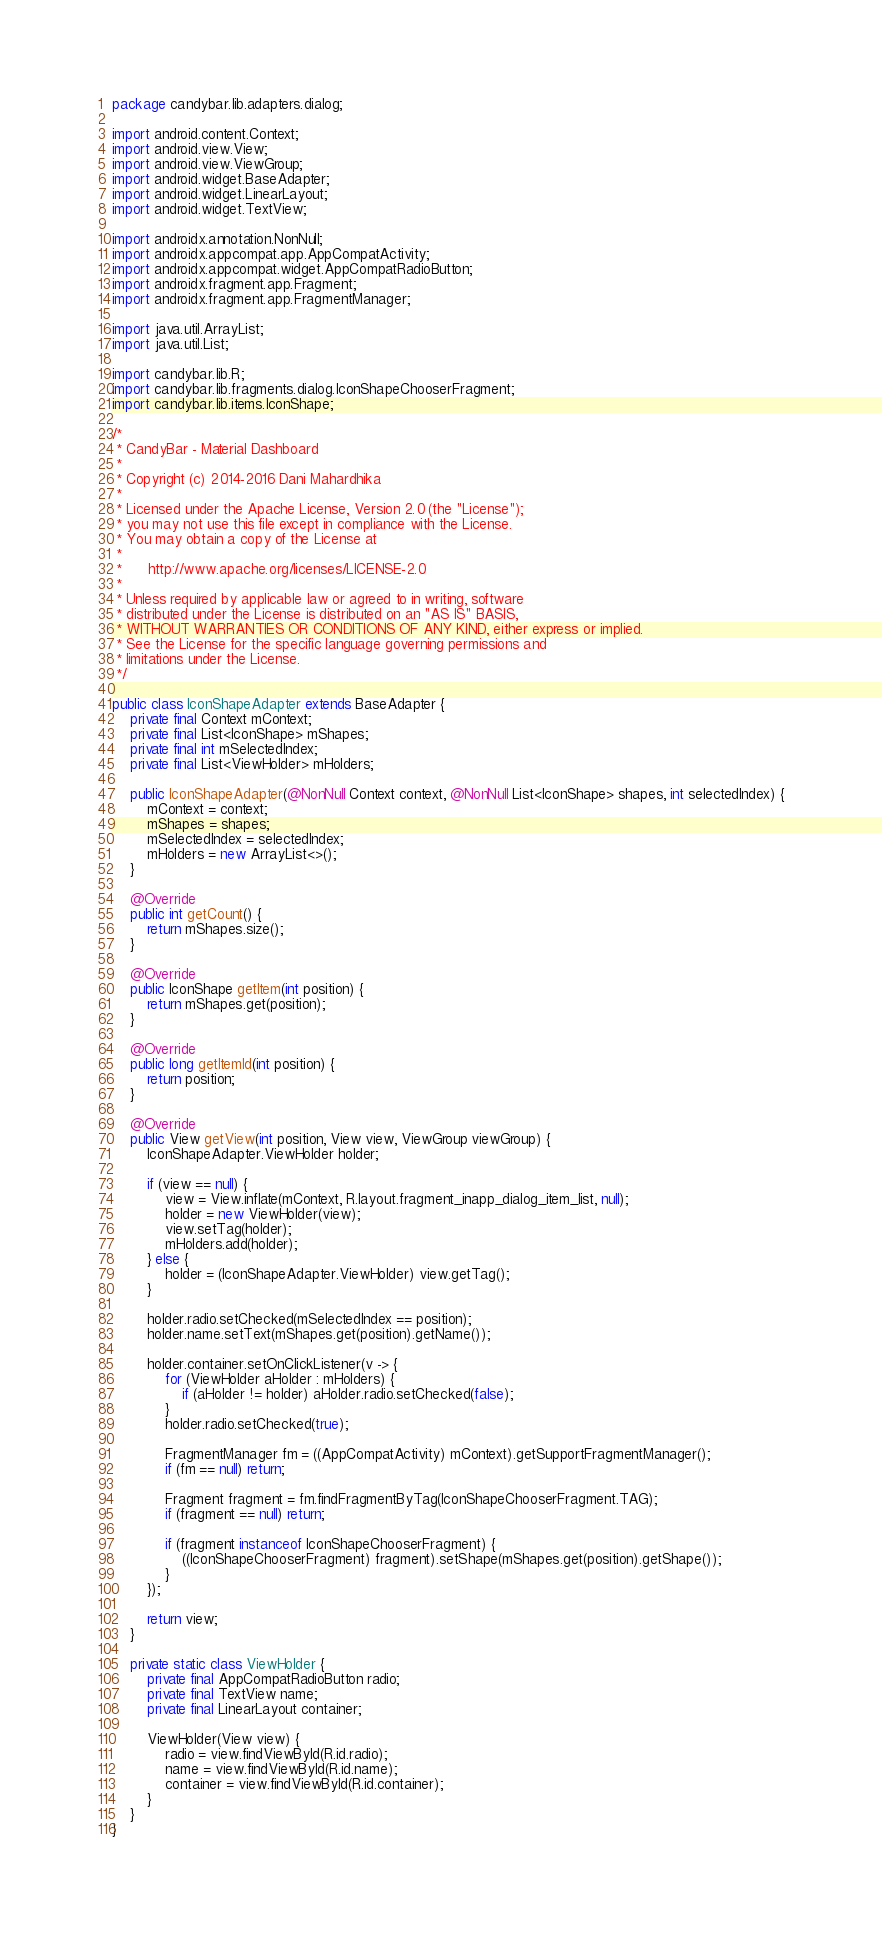<code> <loc_0><loc_0><loc_500><loc_500><_Java_>package candybar.lib.adapters.dialog;

import android.content.Context;
import android.view.View;
import android.view.ViewGroup;
import android.widget.BaseAdapter;
import android.widget.LinearLayout;
import android.widget.TextView;

import androidx.annotation.NonNull;
import androidx.appcompat.app.AppCompatActivity;
import androidx.appcompat.widget.AppCompatRadioButton;
import androidx.fragment.app.Fragment;
import androidx.fragment.app.FragmentManager;

import java.util.ArrayList;
import java.util.List;

import candybar.lib.R;
import candybar.lib.fragments.dialog.IconShapeChooserFragment;
import candybar.lib.items.IconShape;

/*
 * CandyBar - Material Dashboard
 *
 * Copyright (c) 2014-2016 Dani Mahardhika
 *
 * Licensed under the Apache License, Version 2.0 (the "License");
 * you may not use this file except in compliance with the License.
 * You may obtain a copy of the License at
 *
 *      http://www.apache.org/licenses/LICENSE-2.0
 *
 * Unless required by applicable law or agreed to in writing, software
 * distributed under the License is distributed on an "AS IS" BASIS,
 * WITHOUT WARRANTIES OR CONDITIONS OF ANY KIND, either express or implied.
 * See the License for the specific language governing permissions and
 * limitations under the License.
 */

public class IconShapeAdapter extends BaseAdapter {
    private final Context mContext;
    private final List<IconShape> mShapes;
    private final int mSelectedIndex;
    private final List<ViewHolder> mHolders;

    public IconShapeAdapter(@NonNull Context context, @NonNull List<IconShape> shapes, int selectedIndex) {
        mContext = context;
        mShapes = shapes;
        mSelectedIndex = selectedIndex;
        mHolders = new ArrayList<>();
    }

    @Override
    public int getCount() {
        return mShapes.size();
    }

    @Override
    public IconShape getItem(int position) {
        return mShapes.get(position);
    }

    @Override
    public long getItemId(int position) {
        return position;
    }

    @Override
    public View getView(int position, View view, ViewGroup viewGroup) {
        IconShapeAdapter.ViewHolder holder;

        if (view == null) {
            view = View.inflate(mContext, R.layout.fragment_inapp_dialog_item_list, null);
            holder = new ViewHolder(view);
            view.setTag(holder);
            mHolders.add(holder);
        } else {
            holder = (IconShapeAdapter.ViewHolder) view.getTag();
        }

        holder.radio.setChecked(mSelectedIndex == position);
        holder.name.setText(mShapes.get(position).getName());

        holder.container.setOnClickListener(v -> {
            for (ViewHolder aHolder : mHolders) {
                if (aHolder != holder) aHolder.radio.setChecked(false);
            }
            holder.radio.setChecked(true);

            FragmentManager fm = ((AppCompatActivity) mContext).getSupportFragmentManager();
            if (fm == null) return;

            Fragment fragment = fm.findFragmentByTag(IconShapeChooserFragment.TAG);
            if (fragment == null) return;

            if (fragment instanceof IconShapeChooserFragment) {
                ((IconShapeChooserFragment) fragment).setShape(mShapes.get(position).getShape());
            }
        });

        return view;
    }

    private static class ViewHolder {
        private final AppCompatRadioButton radio;
        private final TextView name;
        private final LinearLayout container;

        ViewHolder(View view) {
            radio = view.findViewById(R.id.radio);
            name = view.findViewById(R.id.name);
            container = view.findViewById(R.id.container);
        }
    }
}
</code> 